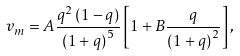<formula> <loc_0><loc_0><loc_500><loc_500>v _ { m } = A \frac { q ^ { 2 } \left ( 1 - q \right ) } { \left ( 1 + q \right ) ^ { 5 } } \left [ 1 + B \frac { q } { \left ( 1 + q \right ) ^ { 2 } } \right ] ,</formula> 